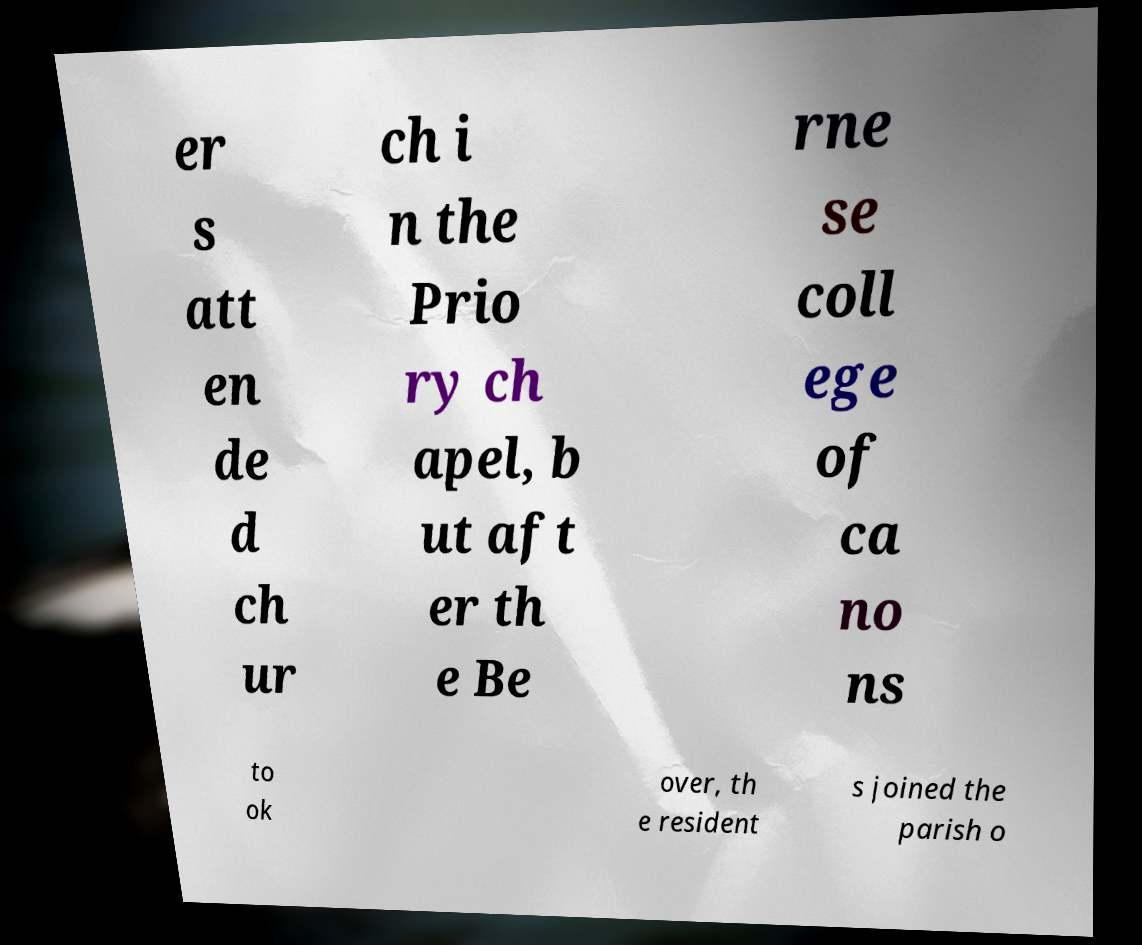I need the written content from this picture converted into text. Can you do that? er s att en de d ch ur ch i n the Prio ry ch apel, b ut aft er th e Be rne se coll ege of ca no ns to ok over, th e resident s joined the parish o 